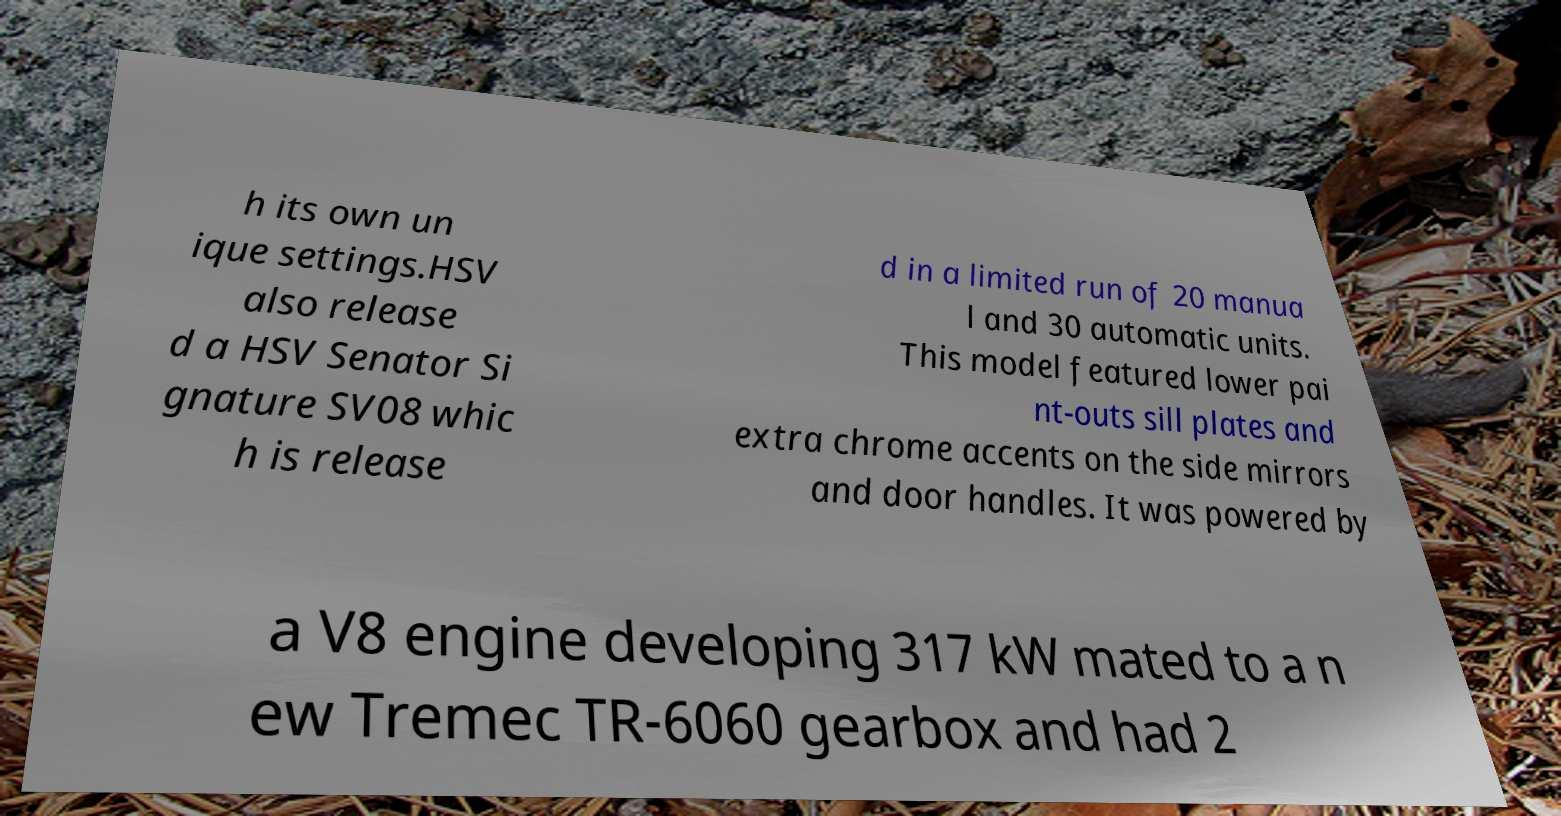Could you extract and type out the text from this image? h its own un ique settings.HSV also release d a HSV Senator Si gnature SV08 whic h is release d in a limited run of 20 manua l and 30 automatic units. This model featured lower pai nt-outs sill plates and extra chrome accents on the side mirrors and door handles. It was powered by a V8 engine developing 317 kW mated to a n ew Tremec TR-6060 gearbox and had 2 